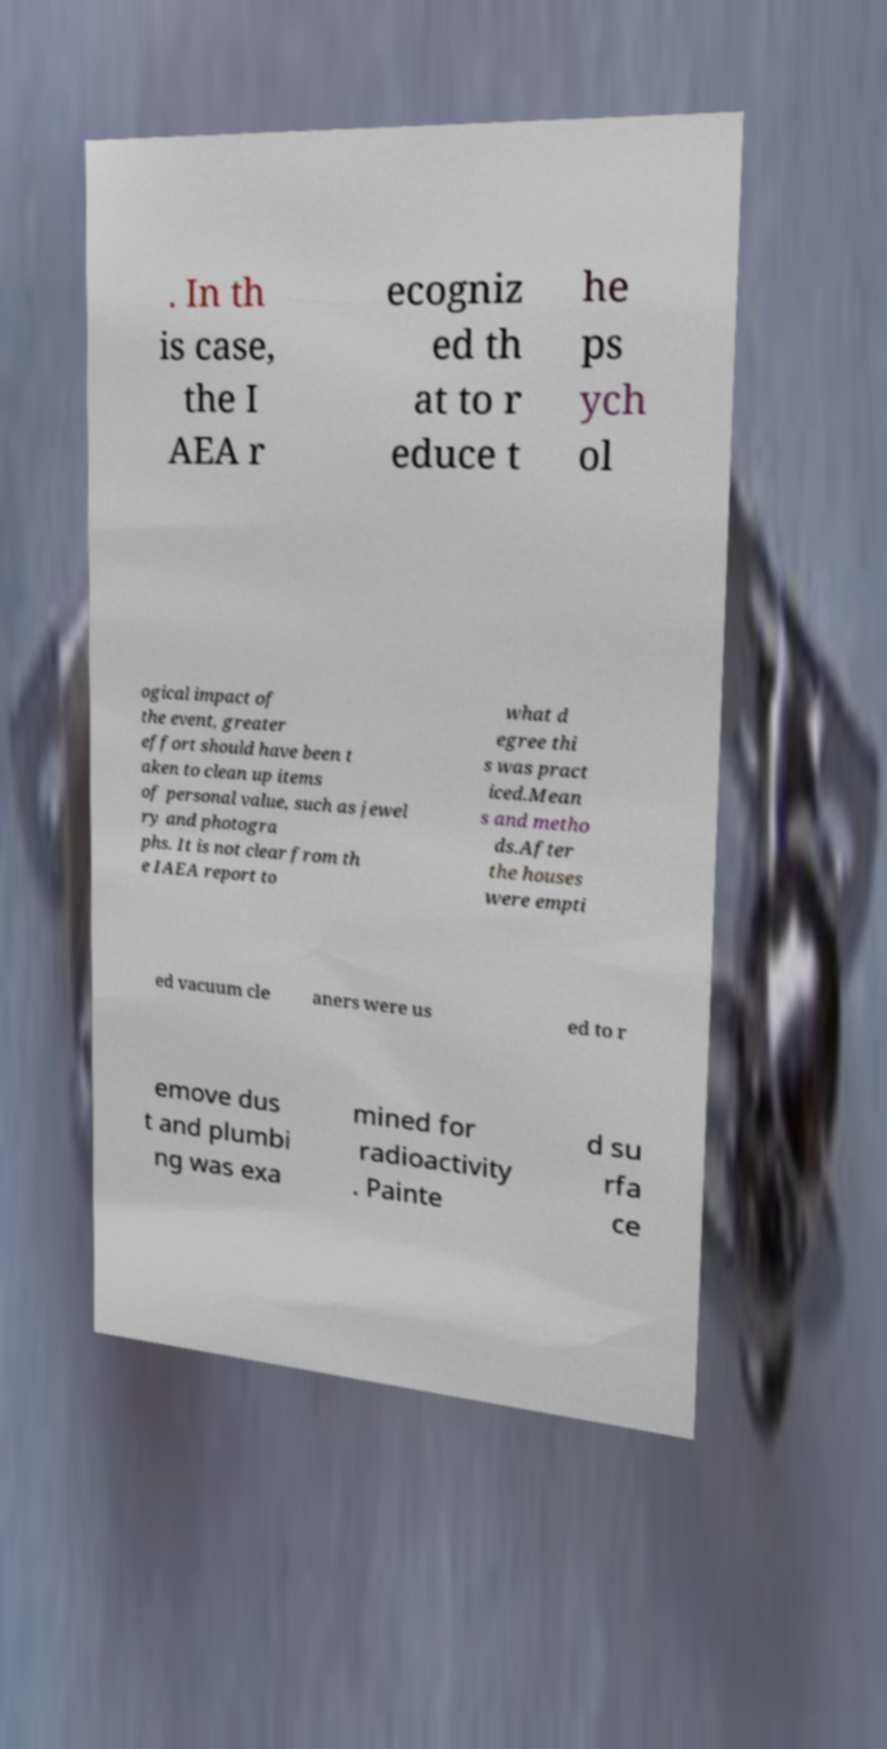Could you extract and type out the text from this image? . In th is case, the I AEA r ecogniz ed th at to r educe t he ps ych ol ogical impact of the event, greater effort should have been t aken to clean up items of personal value, such as jewel ry and photogra phs. It is not clear from th e IAEA report to what d egree thi s was pract iced.Mean s and metho ds.After the houses were empti ed vacuum cle aners were us ed to r emove dus t and plumbi ng was exa mined for radioactivity . Painte d su rfa ce 